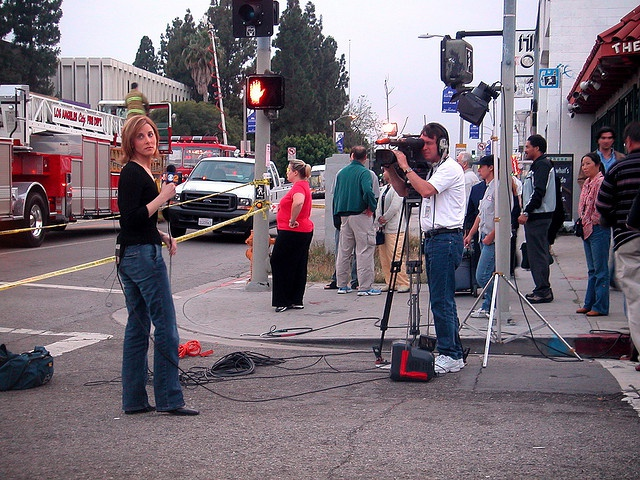Describe the objects in this image and their specific colors. I can see truck in black, darkgray, gray, and lightgray tones, people in black, navy, gray, and brown tones, people in black, lavender, navy, and darkgray tones, truck in black, white, darkgray, and gray tones, and people in black, gray, and teal tones in this image. 